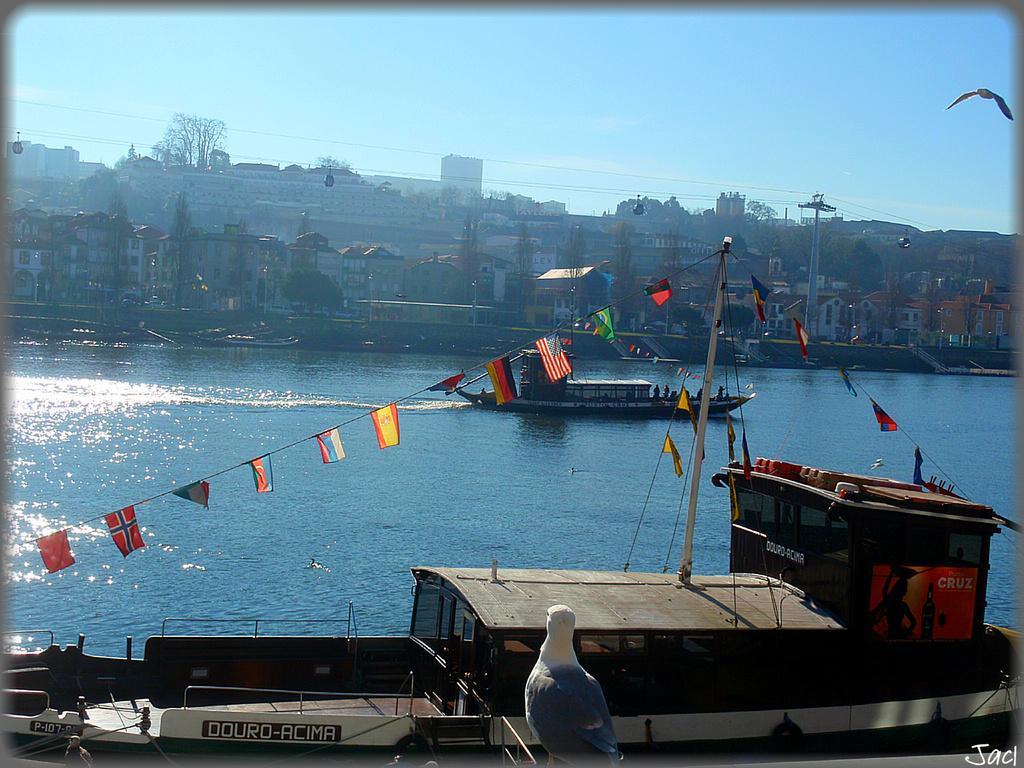How would you summarize this image in a sentence or two? In the picture I can see a bird is in the foreground of the image, I can see two boards are floating on the water, I can see flags tied to the thread, I can see houses, current poles, wires, trees, a bird flying in the air and the blue color sky in the background. 